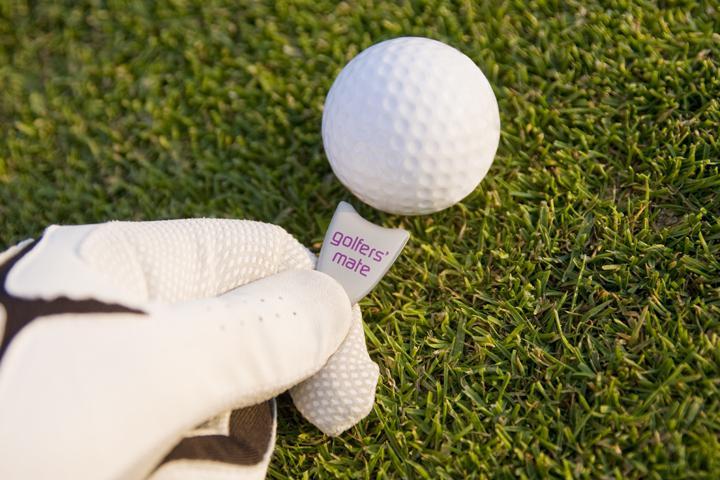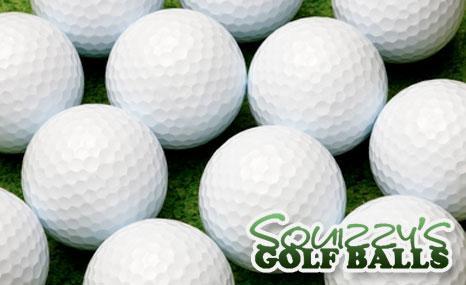The first image is the image on the left, the second image is the image on the right. Analyze the images presented: Is the assertion "At least one image shows only white golf balls with no logo or name markings" valid? Answer yes or no. Yes. 